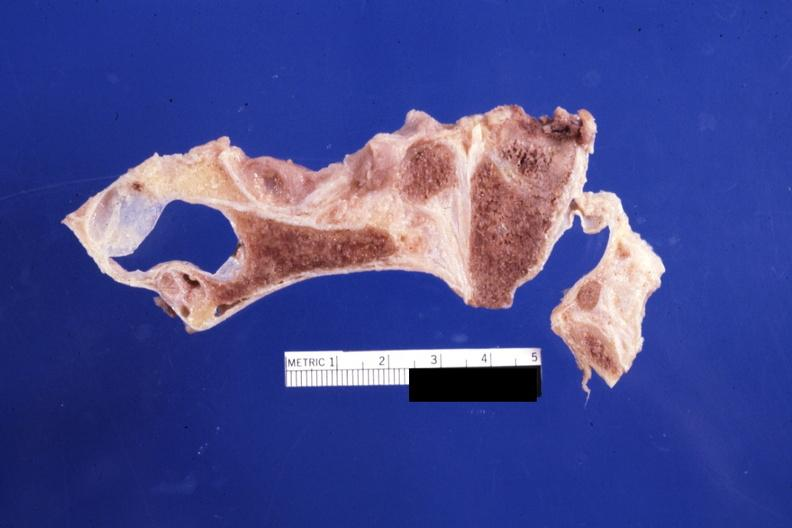does this image show sagittal section of atlas vertebra and occipital bone foramen magnum stenosis case 31?
Answer the question using a single word or phrase. Yes 